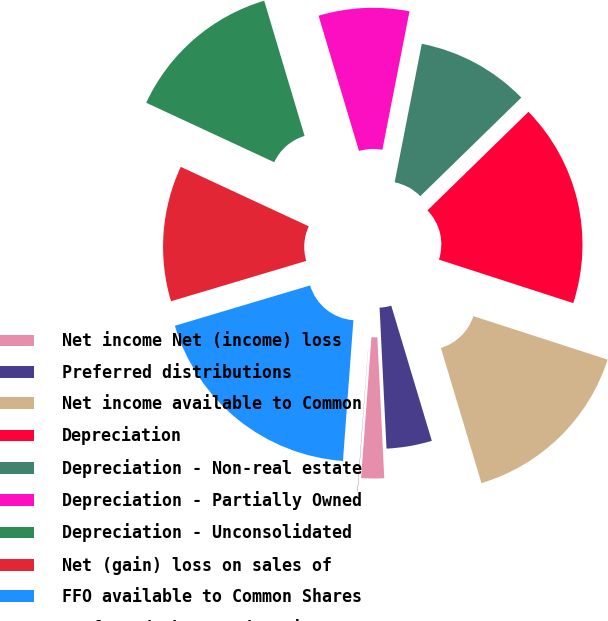Convert chart to OTSL. <chart><loc_0><loc_0><loc_500><loc_500><pie_chart><fcel>Net income Net (income) loss<fcel>Preferred distributions<fcel>Net income available to Common<fcel>Depreciation<fcel>Depreciation - Non-real estate<fcel>Depreciation - Partially Owned<fcel>Depreciation - Unconsolidated<fcel>Net (gain) loss on sales of<fcel>FFO available to Common Shares<fcel>preferred share redemptions<nl><fcel>1.94%<fcel>3.86%<fcel>15.38%<fcel>17.29%<fcel>9.62%<fcel>7.7%<fcel>13.46%<fcel>11.54%<fcel>19.21%<fcel>0.02%<nl></chart> 